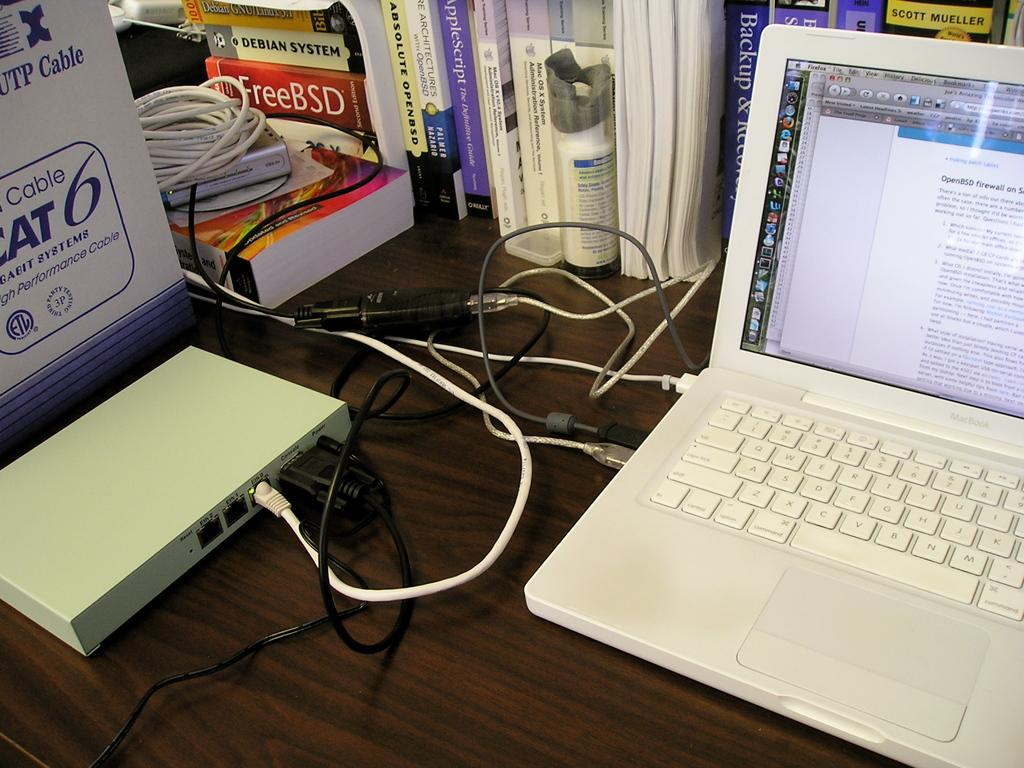<image>
Relay a brief, clear account of the picture shown. A laptop is sitting on the desk in front of books including the book Backup & Recovery. 